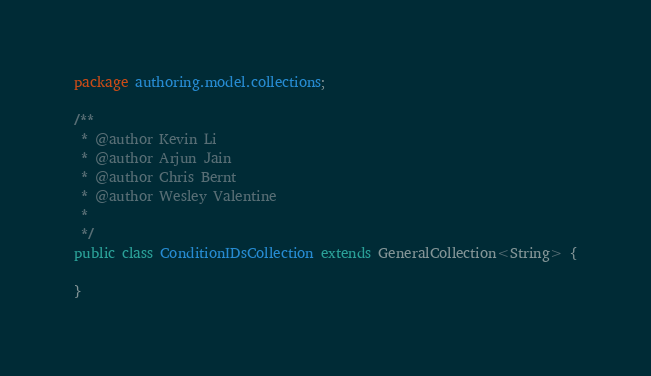<code> <loc_0><loc_0><loc_500><loc_500><_Java_>package authoring.model.collections;

/**
 * @author Kevin Li
 * @author Arjun Jain
 * @author Chris Bernt
 * @author Wesley Valentine
 *
 */
public class ConditionIDsCollection extends GeneralCollection<String> {

}
</code> 